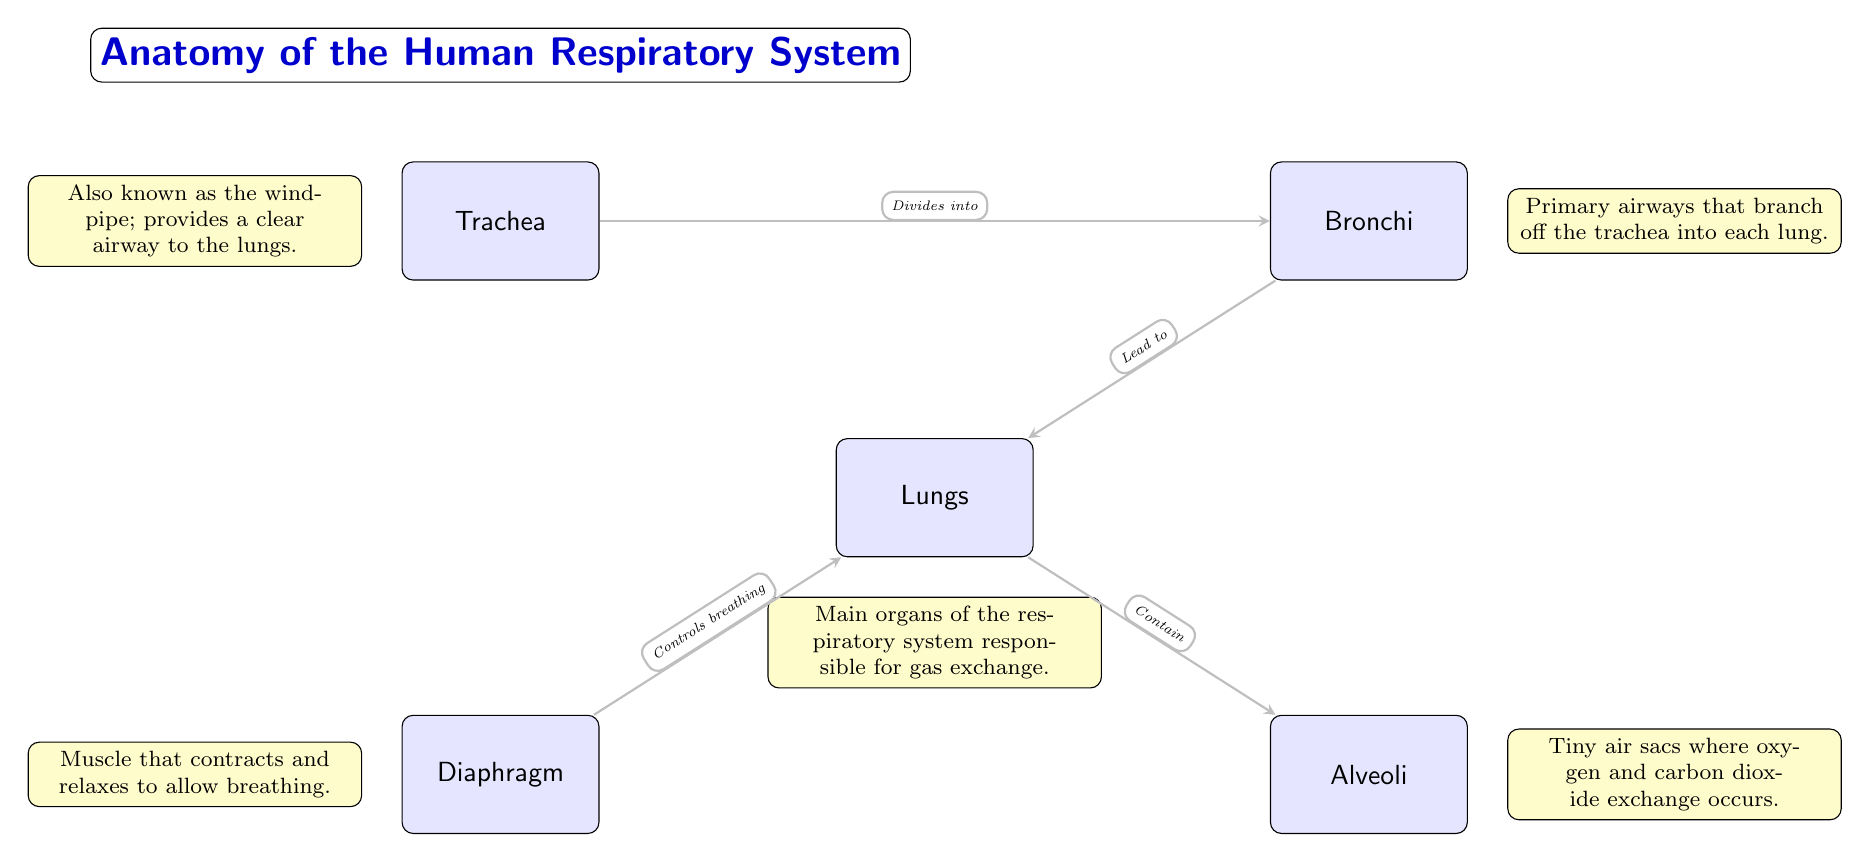What's the main organ of the respiratory system? The diagram indicates that the main organ identified is "Lungs," which is highlighted and has a description below it specifying its role in gas exchange.
Answer: Lungs How does the trachea connect to the bronchi? The diagram shows an arrow labeled "Divides into" indicating the direction of connection from the "Trachea" to the "Bronchi." This indicates that the trachea branches out to form the bronchi.
Answer: Divides into What muscle is responsible for controlling breathing? According to the diagram, "Diaphragm" is mentioned as the muscle that contracts and relaxes to facilitate breathing, which is confirmed in its associated description.
Answer: Diaphragm What are the tiny air sacs in the lungs called? The diagram clearly labels the structures known as "Alveoli," detailing their function as sites for gas exchange, thus making them identifiable by their specific description.
Answer: Alveoli How many main organs are depicted in the diagram? The diagram outlines five distinct structures: Lungs, Trachea, Bronchi, Diaphragm, and Alveoli. Counting each labeled organ confirms that there are in total five main organs represented.
Answer: Five What do the lungs primarily contain? The diagram's arrow from "Lungs" to "Alveoli" is labeled "Contain," which signifies that the primary function of the lungs is to house the alveoli for gas exchange.
Answer: Alveoli What is the relationship between the diaphragm and the lungs? The diagram illustrates an arrow from "Diaphragm" to "Lungs" labeled "Controls breathing," indicating that the diaphragm's function is directly tied to the respiratory mechanics of the lungs.
Answer: Controls breathing What do the bronchi branch off from? The arrow labeled "Divides into" suggests that the "Bronchi" are the result of the trachea branching off, establishing that bronchi are secondary airways formed from the trachea.
Answer: Trachea Which structure provides a clear airway to the lungs? The description for "Trachea" states that it is "Also known as the windpipe; provides a clear airway to the lungs," confirming its essential role in ventilation.
Answer: Windpipe 